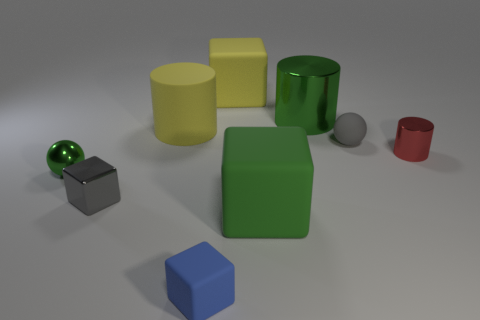There is a rubber thing that is in front of the tiny gray rubber object and to the left of the yellow rubber cube; what shape is it?
Your answer should be very brief. Cube. How many other objects are the same color as the small rubber block?
Your answer should be compact. 0. There is a small gray metallic object; what shape is it?
Ensure brevity in your answer.  Cube. There is a block that is behind the yellow rubber thing left of the tiny blue matte cube; what color is it?
Give a very brief answer. Yellow. Do the large matte cylinder and the block that is to the left of the blue matte thing have the same color?
Your response must be concise. No. There is a green thing that is behind the shiny cube and right of the gray block; what is its material?
Provide a short and direct response. Metal. Is there another cube of the same size as the metal block?
Offer a very short reply. Yes. What material is the gray sphere that is the same size as the red object?
Ensure brevity in your answer.  Rubber. What number of yellow blocks are left of the red object?
Make the answer very short. 1. There is a green metal object behind the tiny gray ball; is its shape the same as the small red thing?
Provide a succinct answer. Yes. 